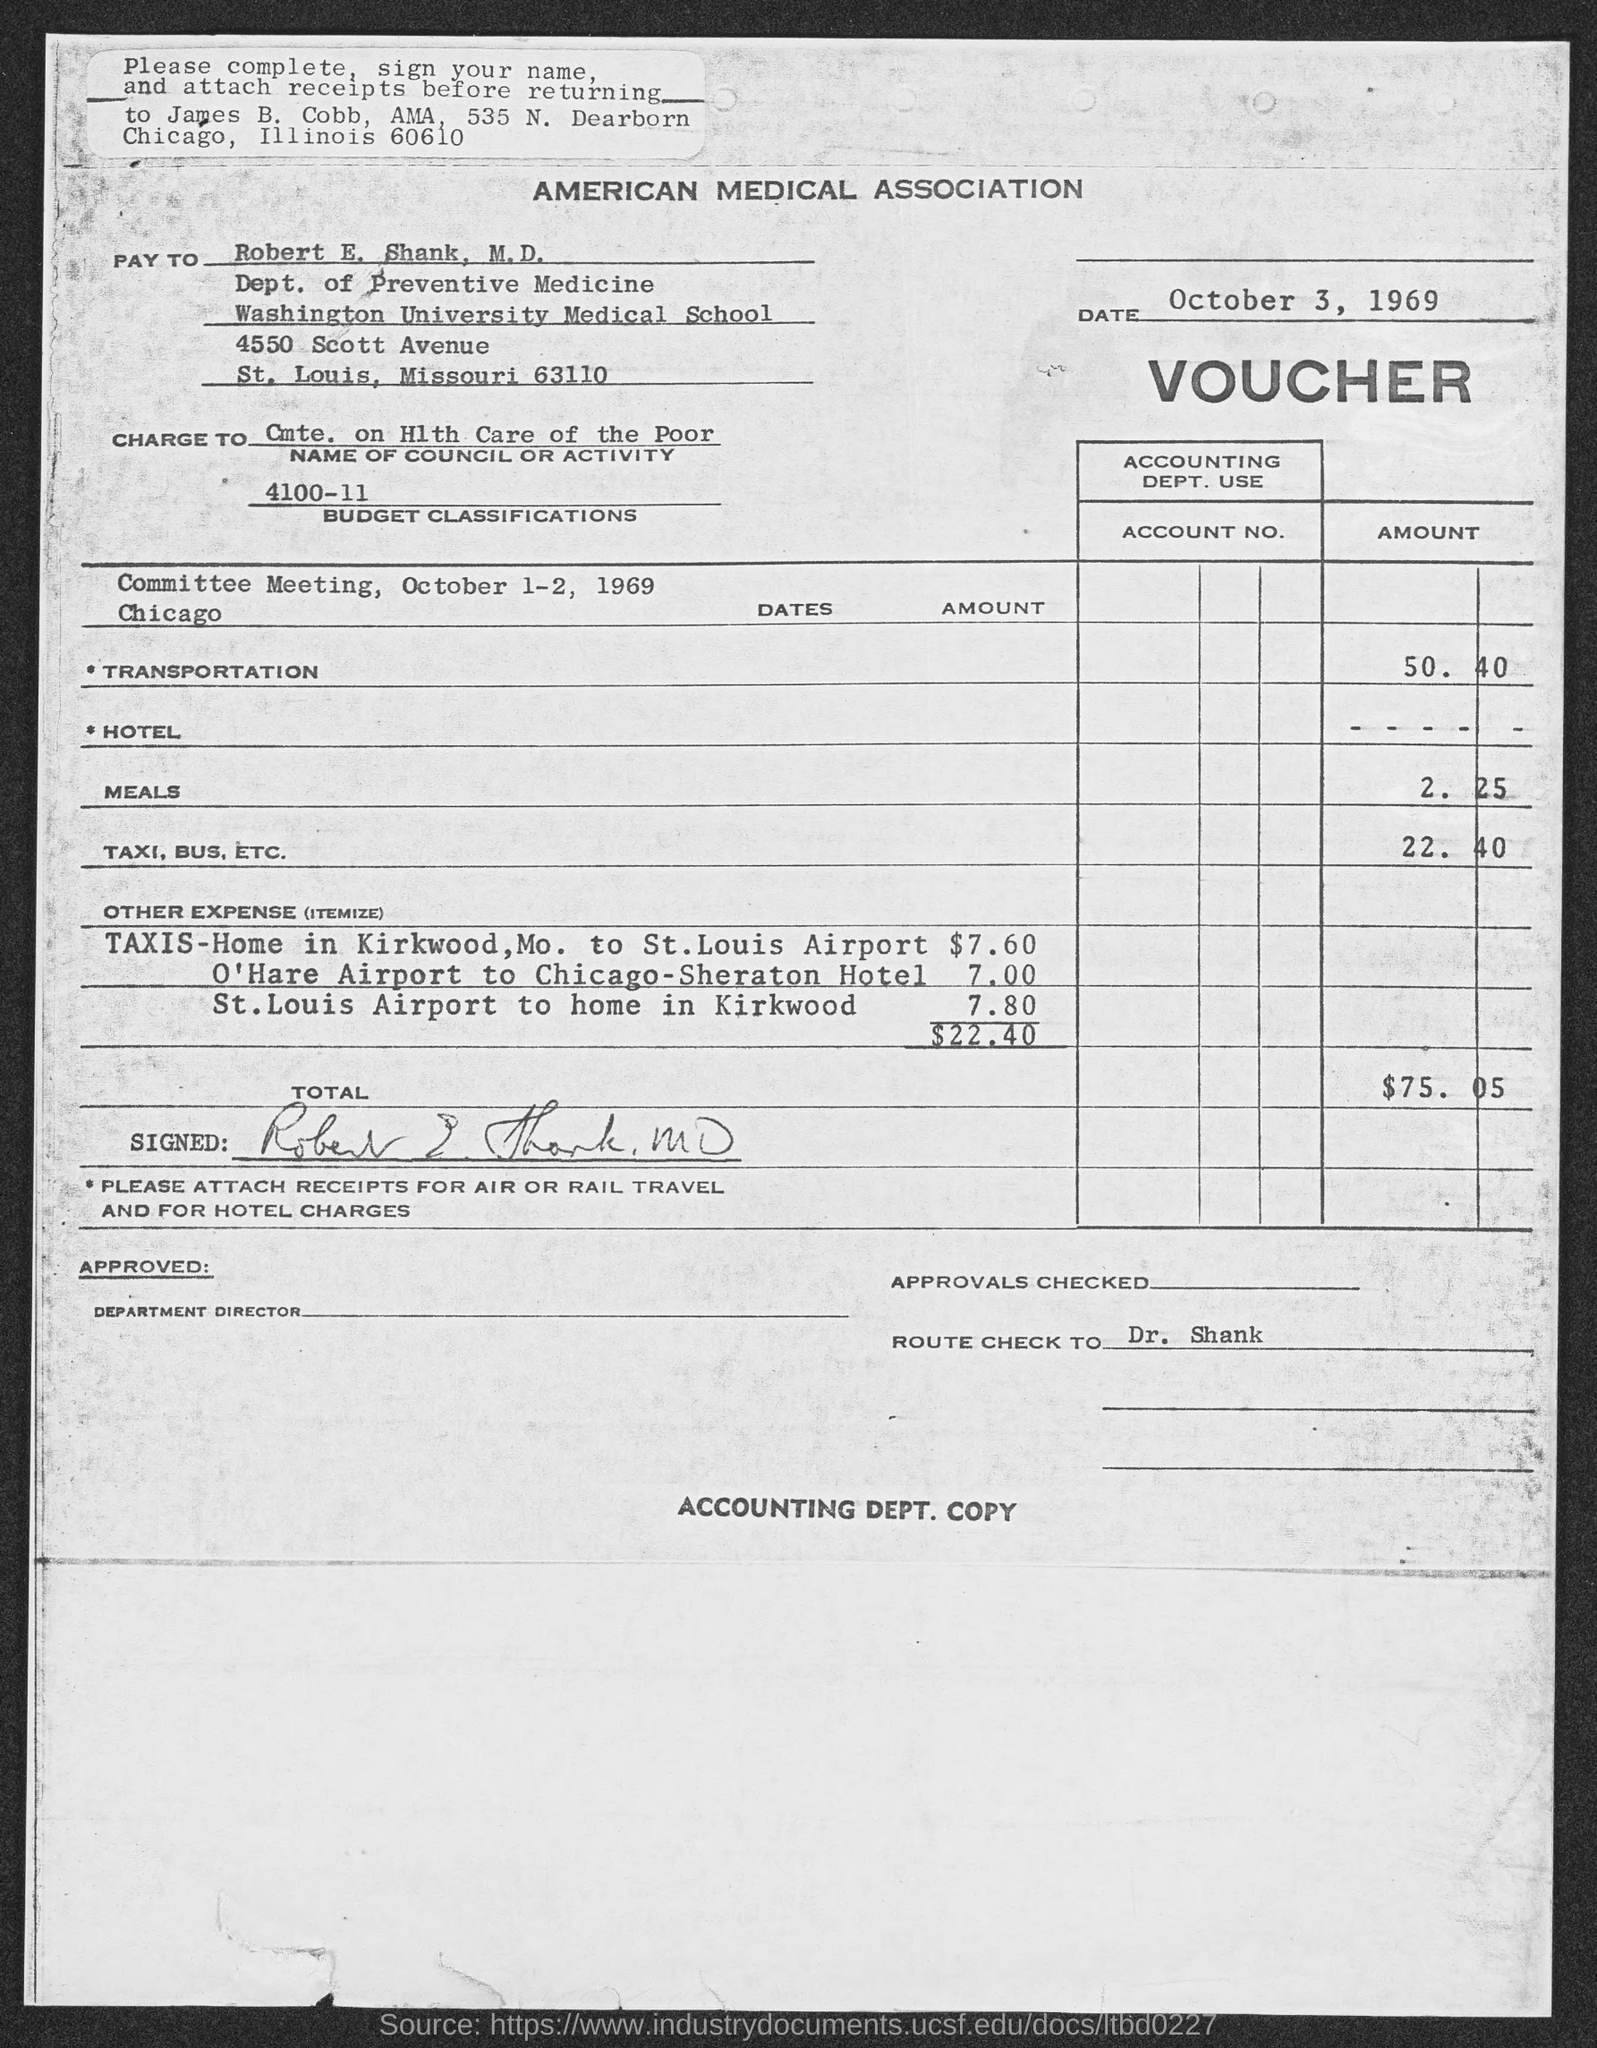Specify some key components in this picture. Washington University Medical School is located in the state of Missouri. 